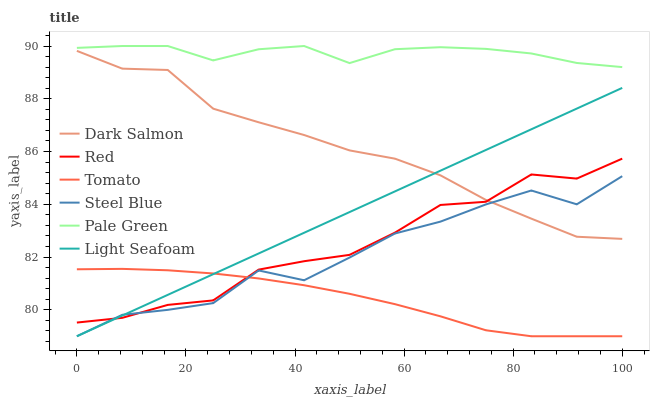Does Dark Salmon have the minimum area under the curve?
Answer yes or no. No. Does Dark Salmon have the maximum area under the curve?
Answer yes or no. No. Is Dark Salmon the smoothest?
Answer yes or no. No. Is Dark Salmon the roughest?
Answer yes or no. No. Does Dark Salmon have the lowest value?
Answer yes or no. No. Does Dark Salmon have the highest value?
Answer yes or no. No. Is Dark Salmon less than Pale Green?
Answer yes or no. Yes. Is Pale Green greater than Red?
Answer yes or no. Yes. Does Dark Salmon intersect Pale Green?
Answer yes or no. No. 